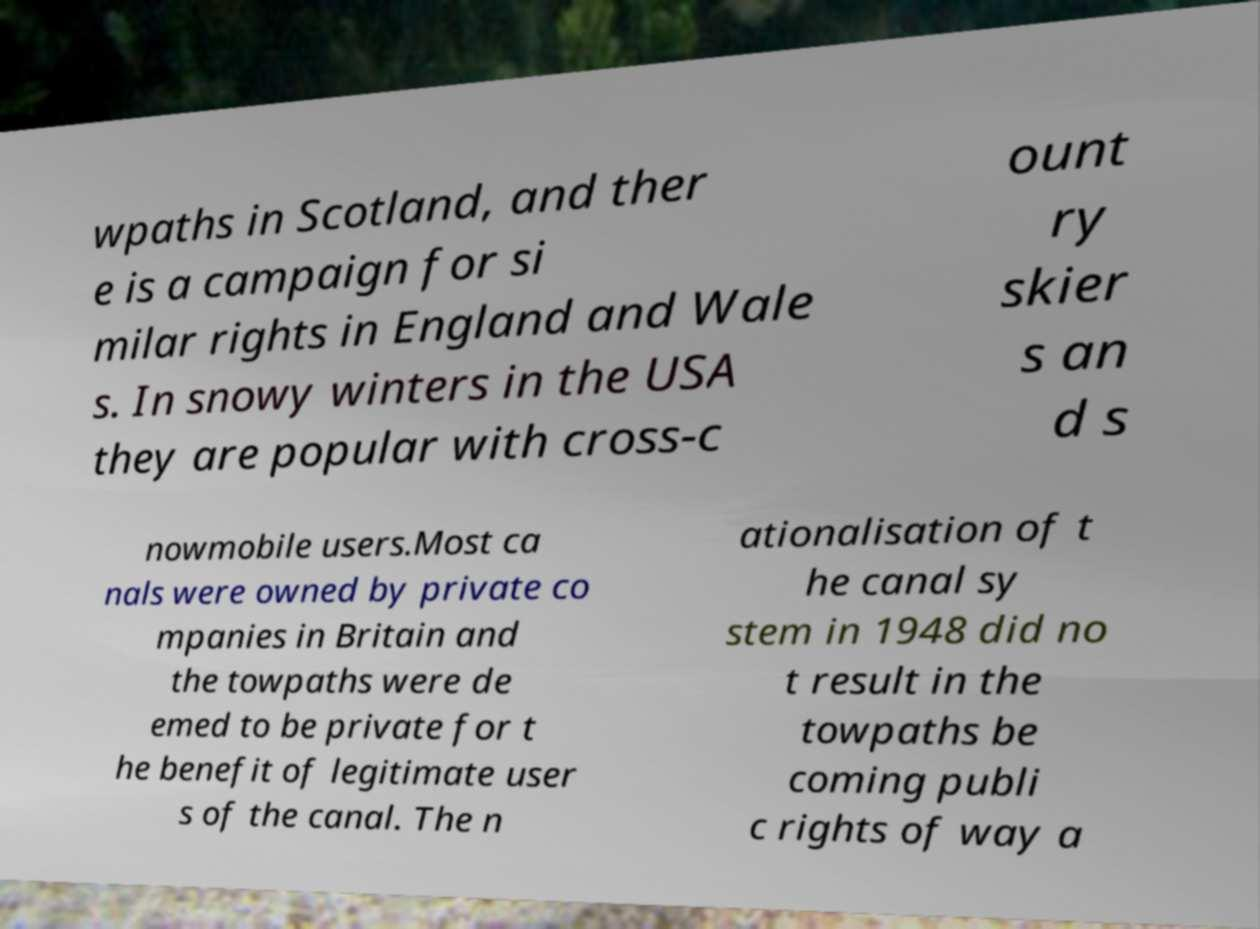Could you extract and type out the text from this image? wpaths in Scotland, and ther e is a campaign for si milar rights in England and Wale s. In snowy winters in the USA they are popular with cross-c ount ry skier s an d s nowmobile users.Most ca nals were owned by private co mpanies in Britain and the towpaths were de emed to be private for t he benefit of legitimate user s of the canal. The n ationalisation of t he canal sy stem in 1948 did no t result in the towpaths be coming publi c rights of way a 